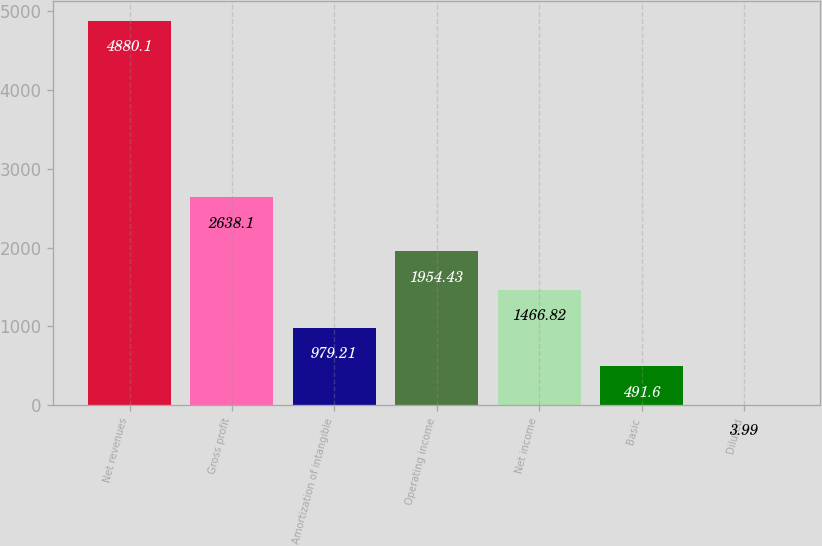Convert chart. <chart><loc_0><loc_0><loc_500><loc_500><bar_chart><fcel>Net revenues<fcel>Gross profit<fcel>Amortization of intangible<fcel>Operating income<fcel>Net income<fcel>Basic<fcel>Diluted<nl><fcel>4880.1<fcel>2638.1<fcel>979.21<fcel>1954.43<fcel>1466.82<fcel>491.6<fcel>3.99<nl></chart> 